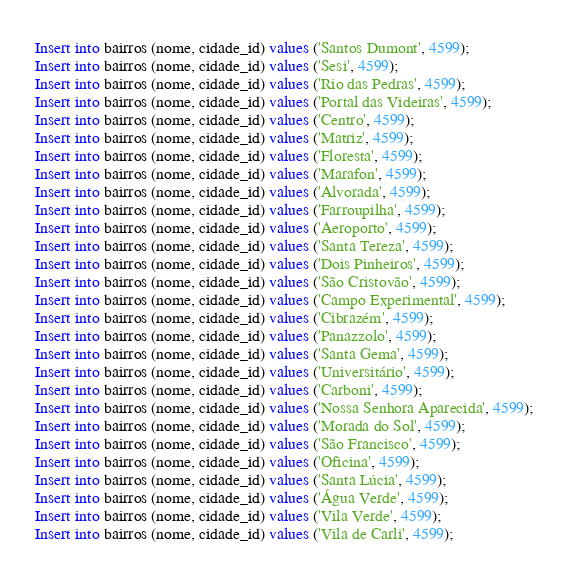<code> <loc_0><loc_0><loc_500><loc_500><_SQL_>Insert into bairros (nome, cidade_id) values ('Santos Dumont', 4599);
Insert into bairros (nome, cidade_id) values ('Sesi', 4599);
Insert into bairros (nome, cidade_id) values ('Rio das Pedras', 4599);
Insert into bairros (nome, cidade_id) values ('Portal das Videiras', 4599);
Insert into bairros (nome, cidade_id) values ('Centro', 4599);
Insert into bairros (nome, cidade_id) values ('Matriz', 4599);
Insert into bairros (nome, cidade_id) values ('Floresta', 4599);
Insert into bairros (nome, cidade_id) values ('Marafon', 4599);
Insert into bairros (nome, cidade_id) values ('Alvorada', 4599);
Insert into bairros (nome, cidade_id) values ('Farroupilha', 4599);
Insert into bairros (nome, cidade_id) values ('Aeroporto', 4599);
Insert into bairros (nome, cidade_id) values ('Santa Tereza', 4599);
Insert into bairros (nome, cidade_id) values ('Dois Pinheiros', 4599);
Insert into bairros (nome, cidade_id) values ('São Cristovão', 4599);
Insert into bairros (nome, cidade_id) values ('Campo Experimental', 4599);
Insert into bairros (nome, cidade_id) values ('Cibrazém', 4599);
Insert into bairros (nome, cidade_id) values ('Panazzolo', 4599);
Insert into bairros (nome, cidade_id) values ('Santa Gema', 4599);
Insert into bairros (nome, cidade_id) values ('Universitário', 4599);
Insert into bairros (nome, cidade_id) values ('Carboni', 4599);
Insert into bairros (nome, cidade_id) values ('Nossa Senhora Aparecida', 4599);
Insert into bairros (nome, cidade_id) values ('Morada do Sol', 4599);
Insert into bairros (nome, cidade_id) values ('São Francisco', 4599);
Insert into bairros (nome, cidade_id) values ('Oficina', 4599);
Insert into bairros (nome, cidade_id) values ('Santa Lúcia', 4599);
Insert into bairros (nome, cidade_id) values ('Água Verde', 4599);
Insert into bairros (nome, cidade_id) values ('Vila Verde', 4599);
Insert into bairros (nome, cidade_id) values ('Vila de Carli', 4599);
</code> 